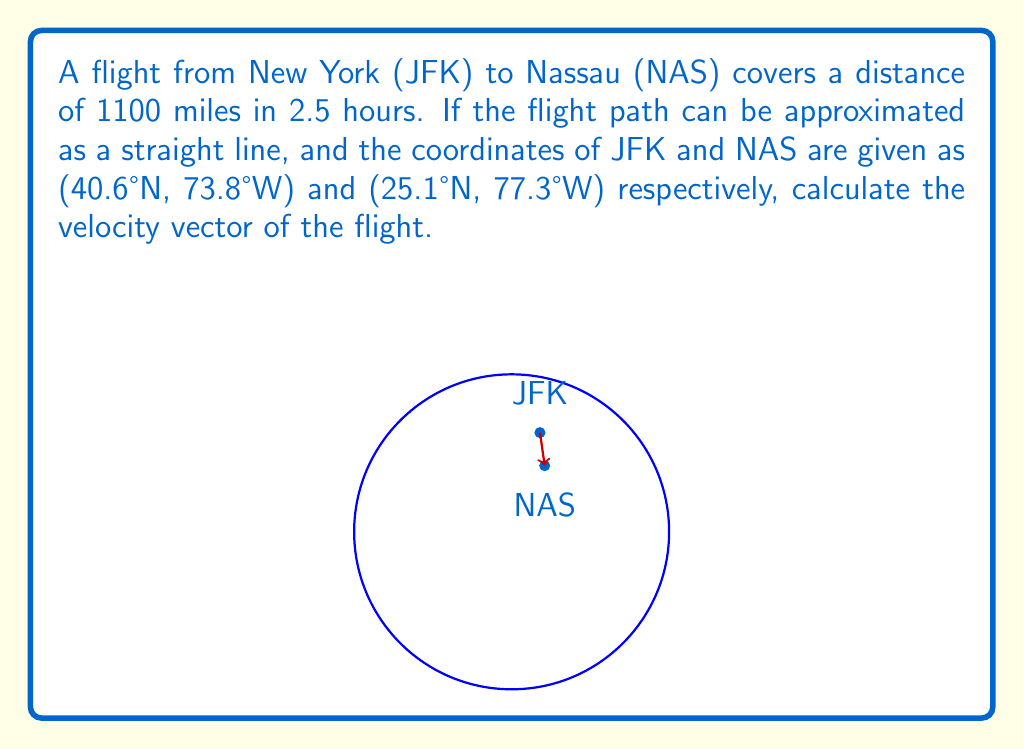Give your solution to this math problem. To solve this problem, we'll follow these steps:

1) First, we need to convert the coordinates to Cartesian (x, y, z) coordinates on a unit sphere. The conversion formulas are:
   $x = \cos(\text{latitude}) \cos(\text{longitude})$
   $y = \cos(\text{latitude}) \sin(\text{longitude})$
   $z = \sin(\text{latitude})$

   For JFK: (40.6°N, 73.8°W) = (0.18, 0.63, 0.76)
   For NAS: (25.1°N, 77.3°W) = (0.21, 0.42, 0.88)

2) The displacement vector $\vec{d}$ is the difference between these points:
   $$\vec{d} = (0.21 - 0.18, 0.42 - 0.63, 0.88 - 0.76) = (0.03, -0.21, 0.12)$$

3) We need to scale this vector to the actual distance of 1100 miles. The scaling factor is:
   $$s = \frac{1100}{\sqrt{0.03^2 + (-0.21)^2 + 0.12^2}} \approx 5049.75$$

4) The scaled displacement vector is:
   $$\vec{D} = s \cdot \vec{d} = (151.49, -1060.45, 605.97) \text{ miles}$$

5) The velocity vector $\vec{v}$ is the displacement vector divided by the time:
   $$\vec{v} = \frac{\vec{D}}{2.5 \text{ hours}} = (60.60, -424.18, 242.39) \text{ miles/hour}$$

6) To express this in a more standard form, we can calculate the magnitude and direction:
   Magnitude: $|\vec{v}| = \sqrt{60.60^2 + (-424.18)^2 + 242.39^2} \approx 440 \text{ mph}$
   
   Direction: We can express this as two angles:
   - Angle from x-axis in xy-plane: $\theta = \tan^{-1}(-424.18/60.60) \approx -81.86°$
   - Angle from xy-plane: $\phi = \sin^{-1}(242.39/440) \approx 33.29°$
Answer: $\vec{v} = 440 \text{ mph at } -81.86° \text{ from x-axis and } 33.29° \text{ above xy-plane}$ 